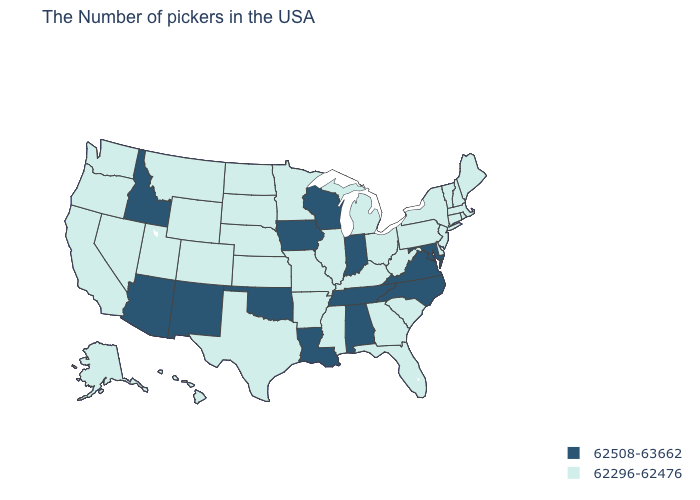Does North Dakota have the highest value in the MidWest?
Answer briefly. No. Is the legend a continuous bar?
Concise answer only. No. What is the lowest value in the USA?
Concise answer only. 62296-62476. Does Idaho have a lower value than Michigan?
Answer briefly. No. What is the value of West Virginia?
Keep it brief. 62296-62476. Does Indiana have a higher value than Wyoming?
Be succinct. Yes. Does the map have missing data?
Give a very brief answer. No. Does Arizona have the same value as Illinois?
Be succinct. No. What is the value of New Jersey?
Answer briefly. 62296-62476. Does the map have missing data?
Quick response, please. No. Does the first symbol in the legend represent the smallest category?
Answer briefly. No. What is the value of New Jersey?
Quick response, please. 62296-62476. What is the lowest value in the USA?
Quick response, please. 62296-62476. What is the value of Missouri?
Quick response, please. 62296-62476. Does Florida have a lower value than Arizona?
Be succinct. Yes. 